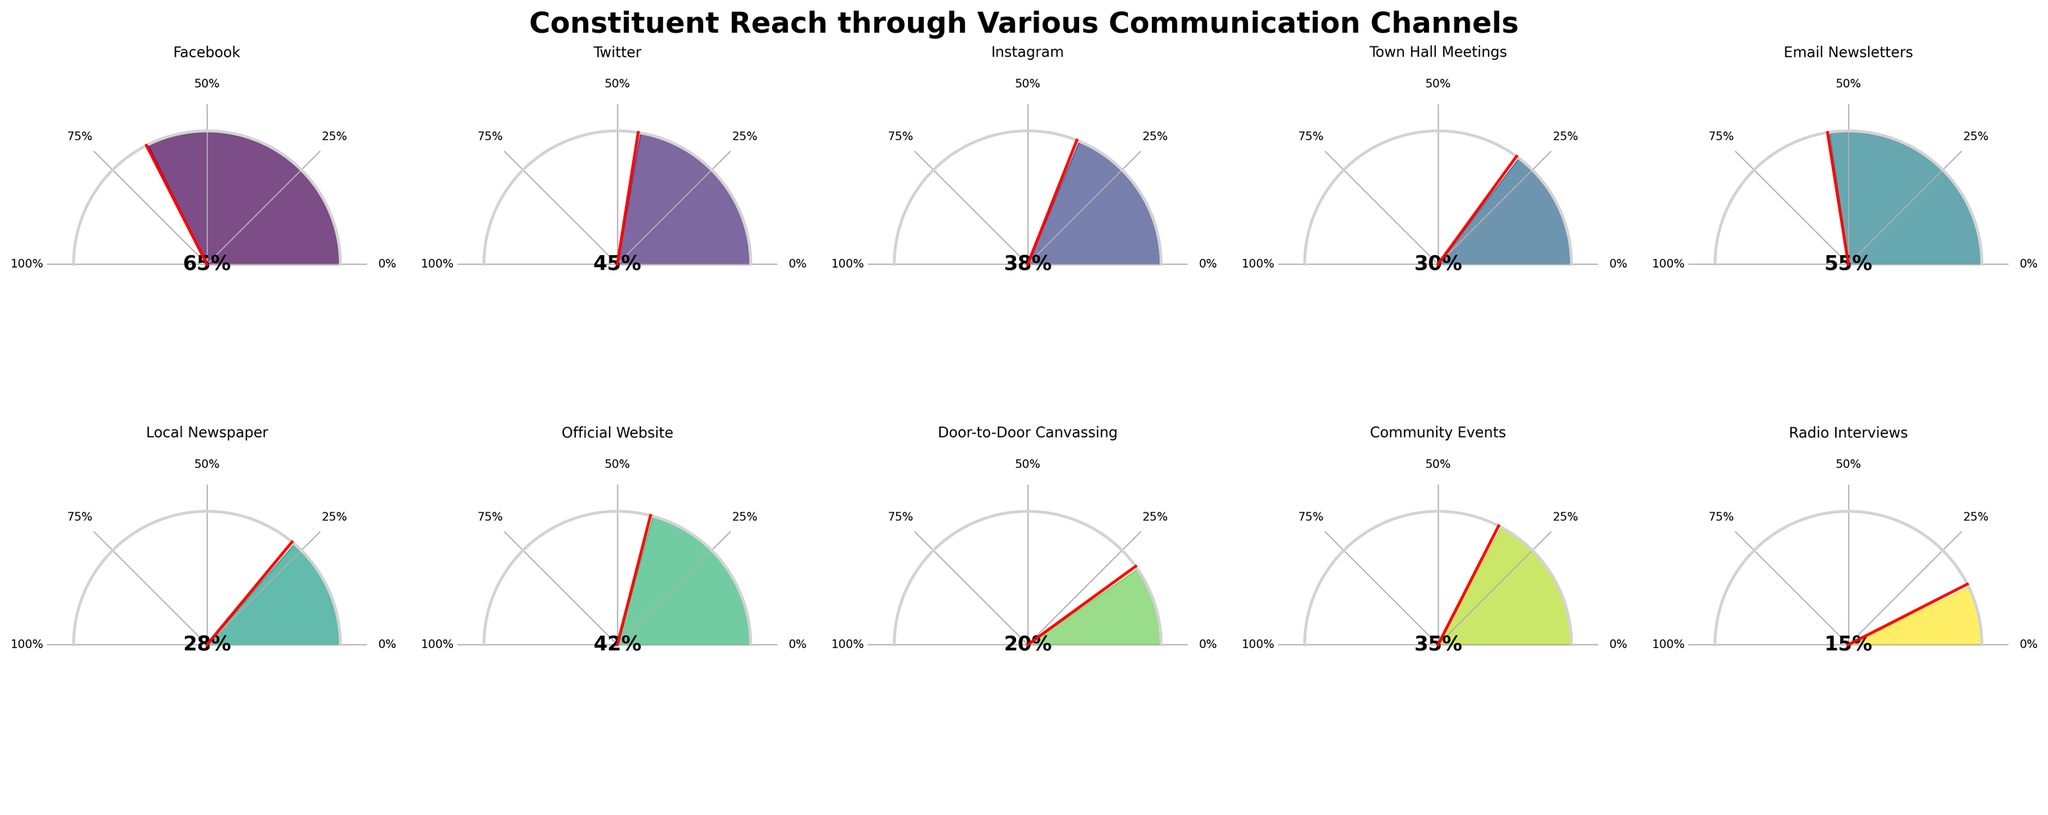What's the title of the figure? The title of the figure can be observed at the top, it reads "Constituent Reach through Various Communication Channels" which provides a summary of the data presented.
Answer: Constituent Reach through Various Communication Channels Which communication channel reaches 65% of the constituents? To find the channel reaching 65% of constituents, look at the needle on the gauge chart that points to "65%", which is labeled as "Facebook".
Answer: Facebook What is the percentage of constituents reached through Email Newsletters? Locate the gauge chart labeled "Email Newsletters" and check the percentage indicated by the needle, which reads "55%".
Answer: 55% How many communication channels reach more than 50% of the constituents? Identify the channels with gauge needles pointing to more than "50%". These include "Facebook (65%), Twitter (45%), Instagram (38%), Town Hall Meetings (30%), Email Newsletters (55%), Local Newspaper (28%), Official Website (42%), Door-to-Door Canvassing (20%), Community Events (35%), Radio Interviews (15%)". Only "Facebook" and "Email Newsletters" are above 50%.
Answer: 2 Which communication channel has the lowest reach, and what is the percentage? Check all the needles and identify the one pointing to the minimum value, "15%", which is labeled as "Radio Interviews".
Answer: Radio Interviews, 15% What is the sum of the percentages for social media platforms (Facebook, Twitter, and Instagram)? Add the percentages for Facebook (65%), Twitter (45%), and Instagram (38%) to get the total: 65 + 45 + 38 = 148.
Answer: 148 What is the average percentage reach for traditional media channels (Local Newspaper and Radio Interviews)? Calculate the average by adding percentages for Local Newspaper (28%) and Radio Interviews (15%) and then divide by 2: (28 + 15) / 2 = 21.5.
Answer: 21.5 Which channel out of Town Hall Meetings, Community Events, and Door-to-Door Canvassing has the highest reach? Compare the percentages of Town Hall Meetings (30%), Community Events (35%), and Door-to-Door Canvassing (20%). The highest is "Community Events" with 35%.
Answer: Community Events What is the percentage difference between the reach of Twitter and the Official Website? Subtract the lower percentage (Official Website, 42%) from the higher percentage (Twitter, 45%): 45% - 42% = 3%.
Answer: 3% How does the reach of the Official Website compare to Door-to-Door Canvassing? Compare the percentages where Official Website is 42% and Door-to-Door Canvassing is 20%. Official Website has a higher reach.
Answer: Official Website has a higher reach 